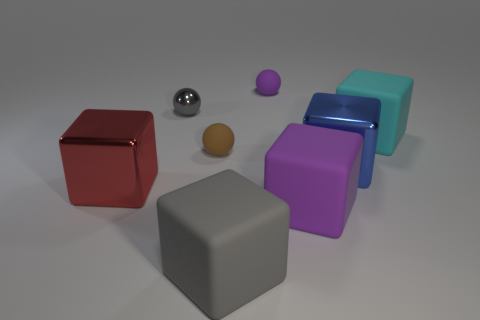Subtract all gray matte blocks. How many blocks are left? 4 Subtract all purple blocks. How many blocks are left? 4 Subtract all brown cubes. Subtract all brown balls. How many cubes are left? 5 Add 1 gray matte things. How many objects exist? 9 Subtract all blocks. How many objects are left? 3 Subtract 0 brown cylinders. How many objects are left? 8 Subtract all rubber things. Subtract all big cyan cubes. How many objects are left? 2 Add 5 rubber spheres. How many rubber spheres are left? 7 Add 6 red shiny things. How many red shiny things exist? 7 